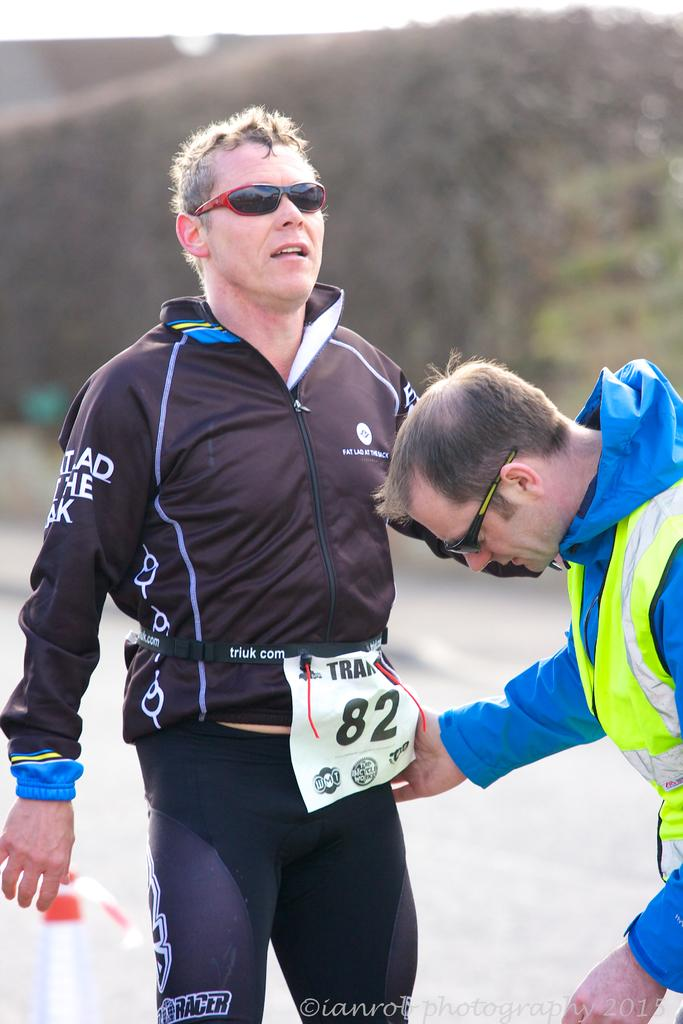<image>
Create a compact narrative representing the image presented. An athlete with a number around his waist that reads 82. 